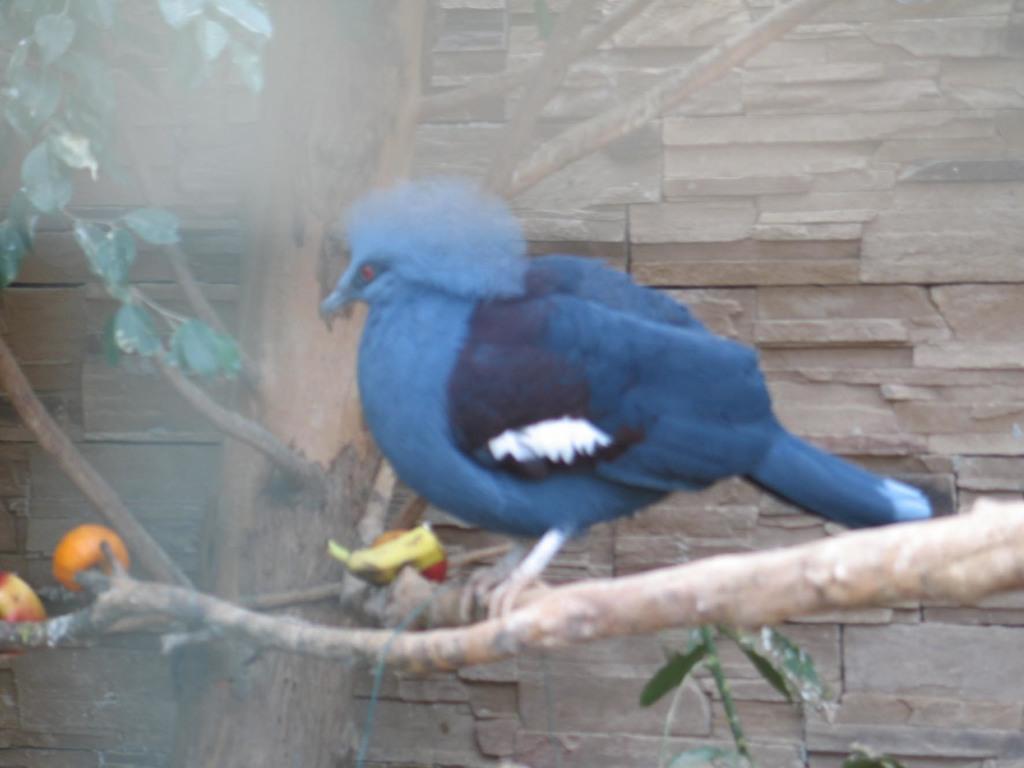Can you describe this image briefly? In this image I can see a bird on the tree and the bird is in blue color, and I can see leaves in green color and some object in orange color. Background the wall is in brown color. 